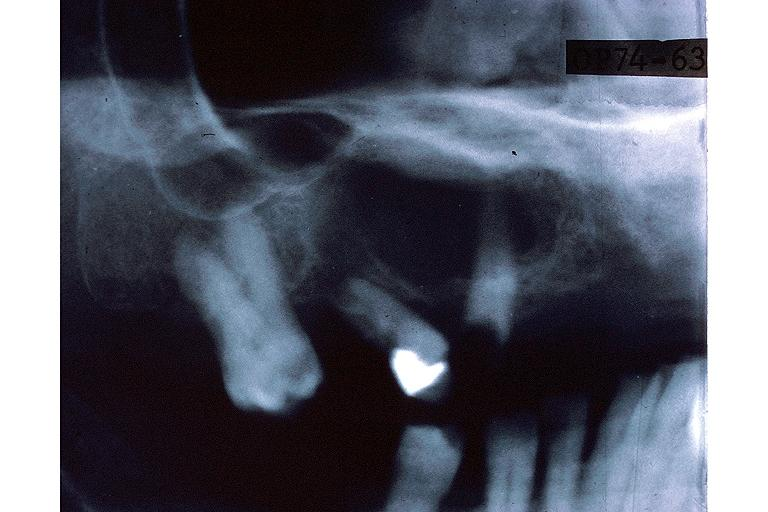what does this image show?
Answer the question using a single word or phrase. Central giant cell lesion 